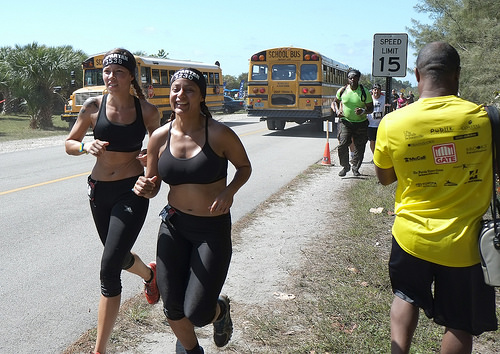<image>
Can you confirm if the bus is on the road? Yes. Looking at the image, I can see the bus is positioned on top of the road, with the road providing support. Is the girl on the girl? No. The girl is not positioned on the girl. They may be near each other, but the girl is not supported by or resting on top of the girl. Is the woman behind the school bus? Yes. From this viewpoint, the woman is positioned behind the school bus, with the school bus partially or fully occluding the woman. Is the woman in front of the bus? No. The woman is not in front of the bus. The spatial positioning shows a different relationship between these objects. 